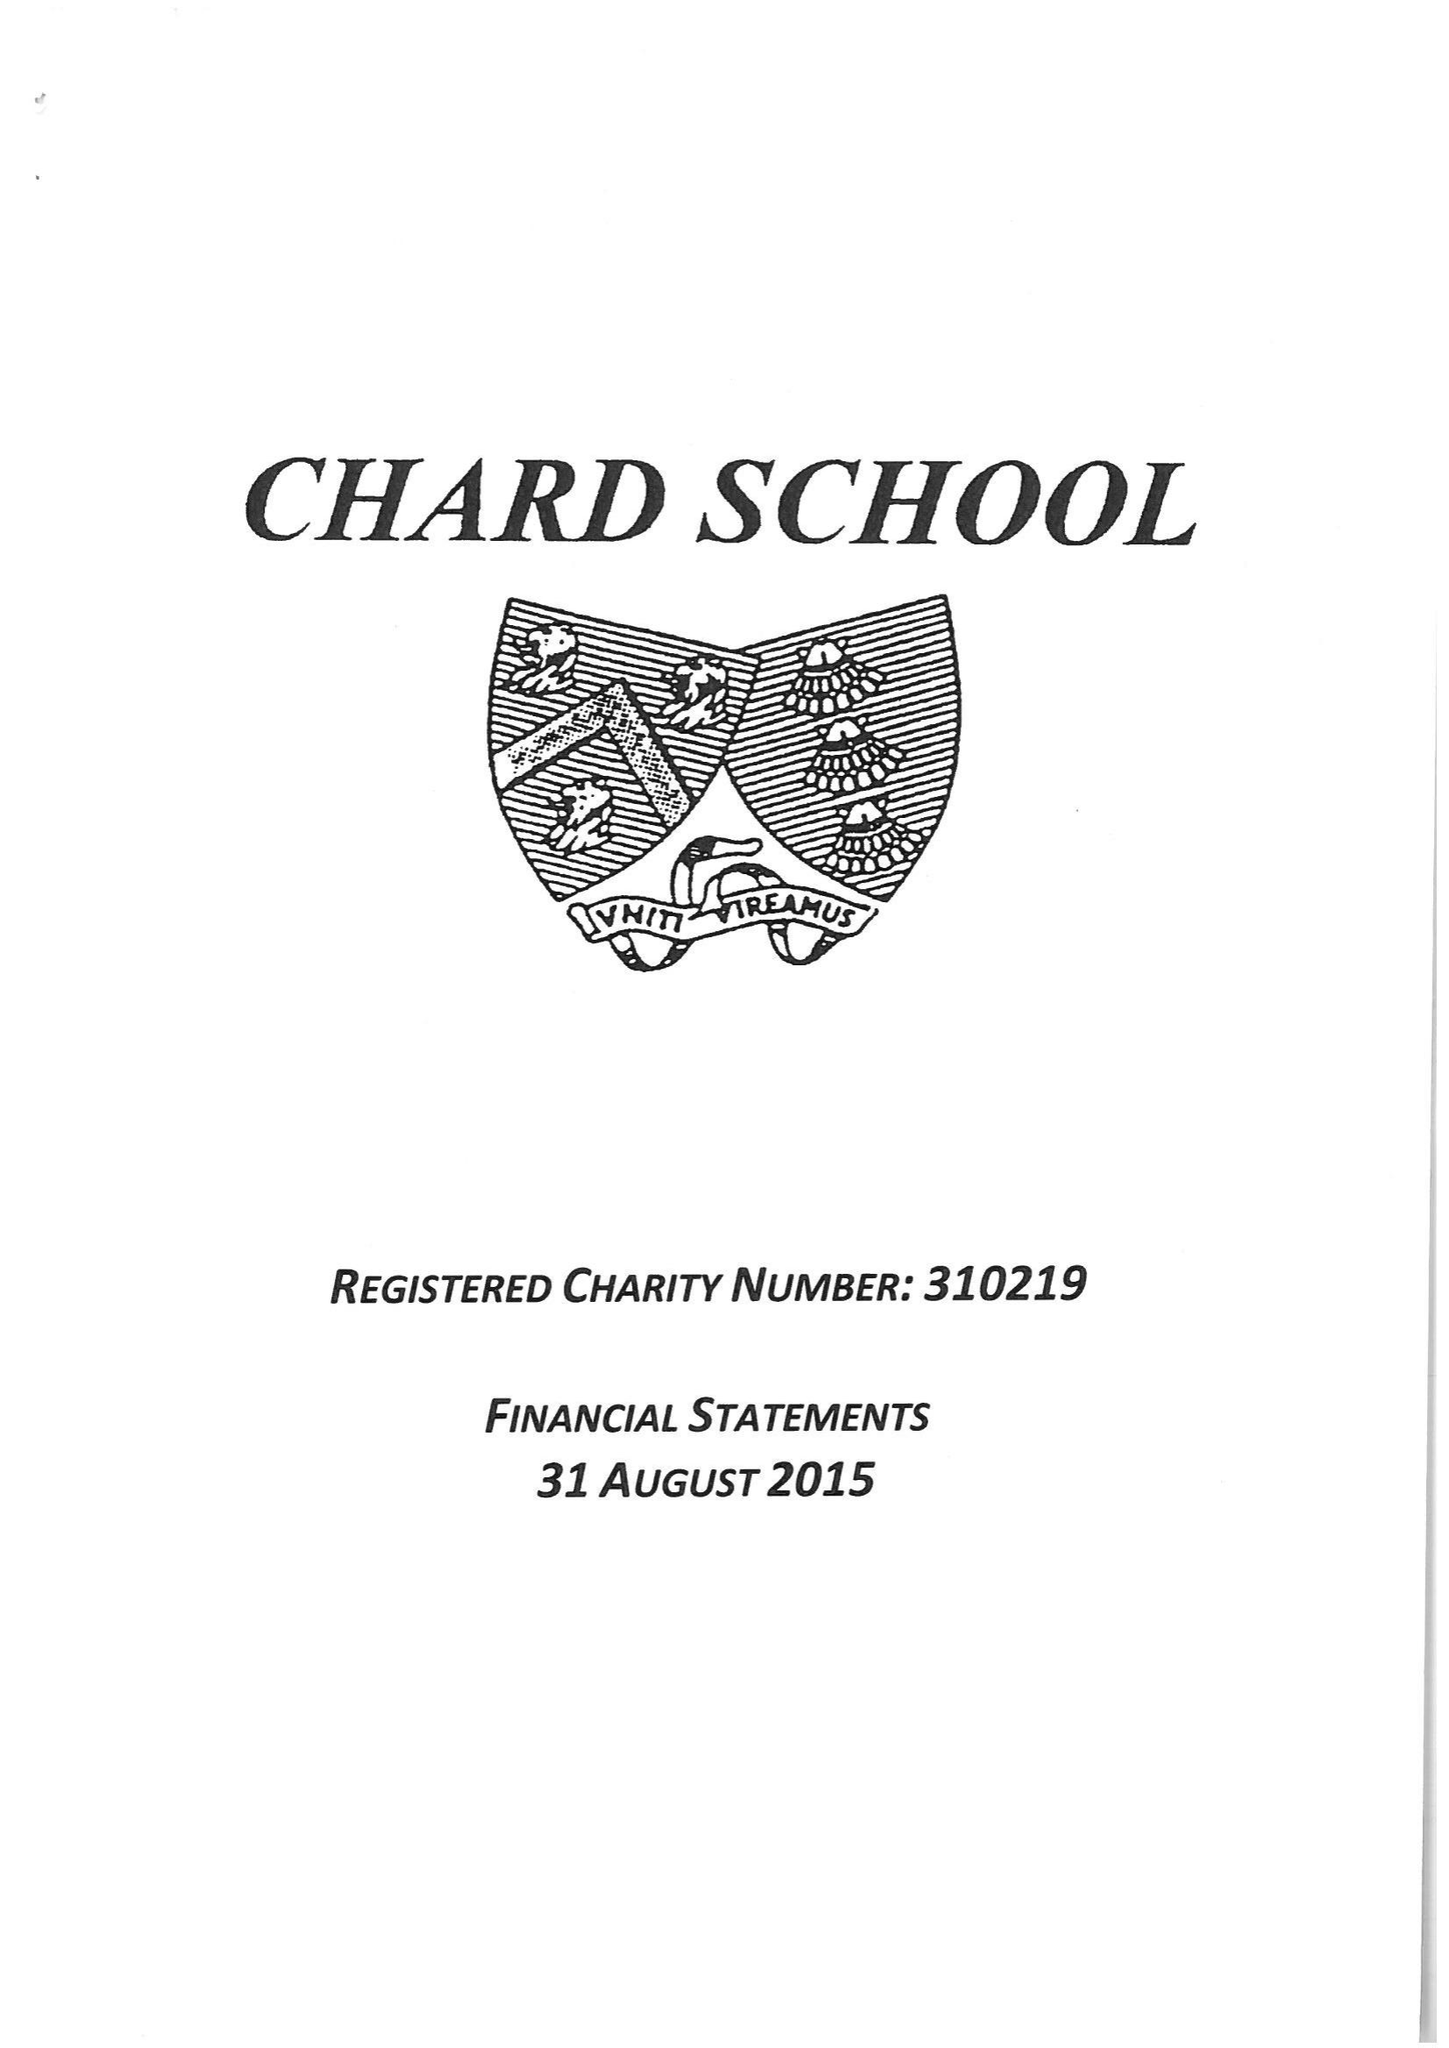What is the value for the charity_name?
Answer the question using a single word or phrase. Chard School 